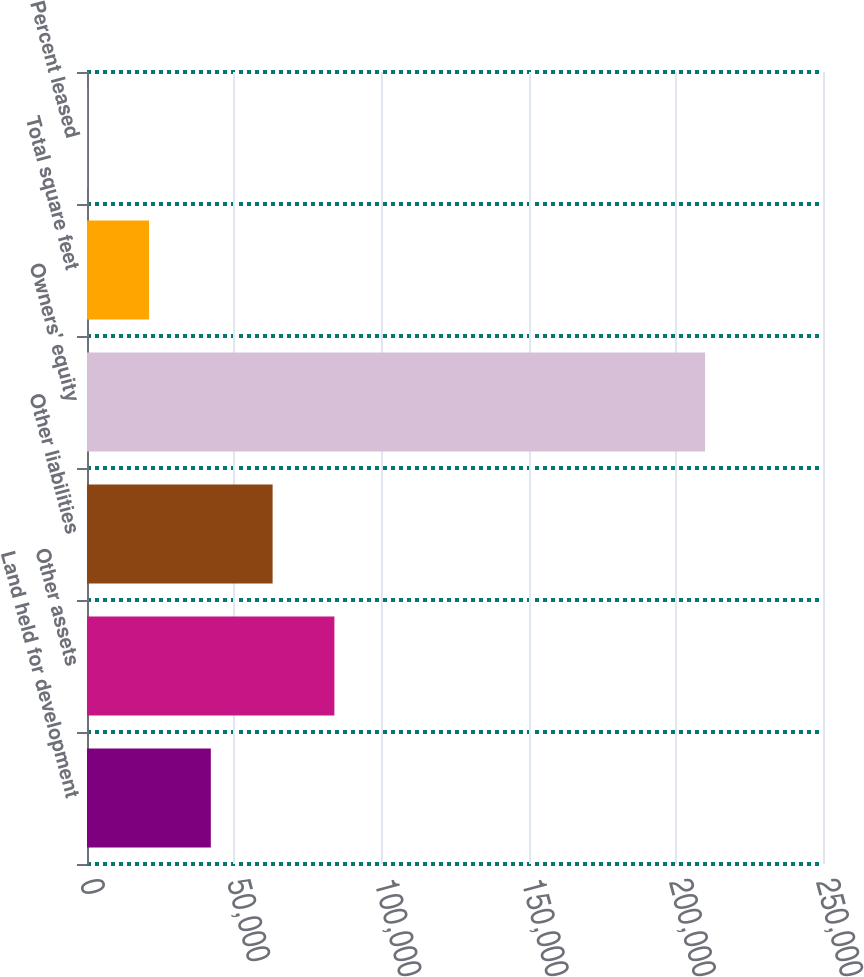Convert chart. <chart><loc_0><loc_0><loc_500><loc_500><bar_chart><fcel>Land held for development<fcel>Other assets<fcel>Other liabilities<fcel>Owners' equity<fcel>Total square feet<fcel>Percent leased<nl><fcel>42063<fcel>84035.2<fcel>63049.1<fcel>209952<fcel>21076.8<fcel>90.7<nl></chart> 